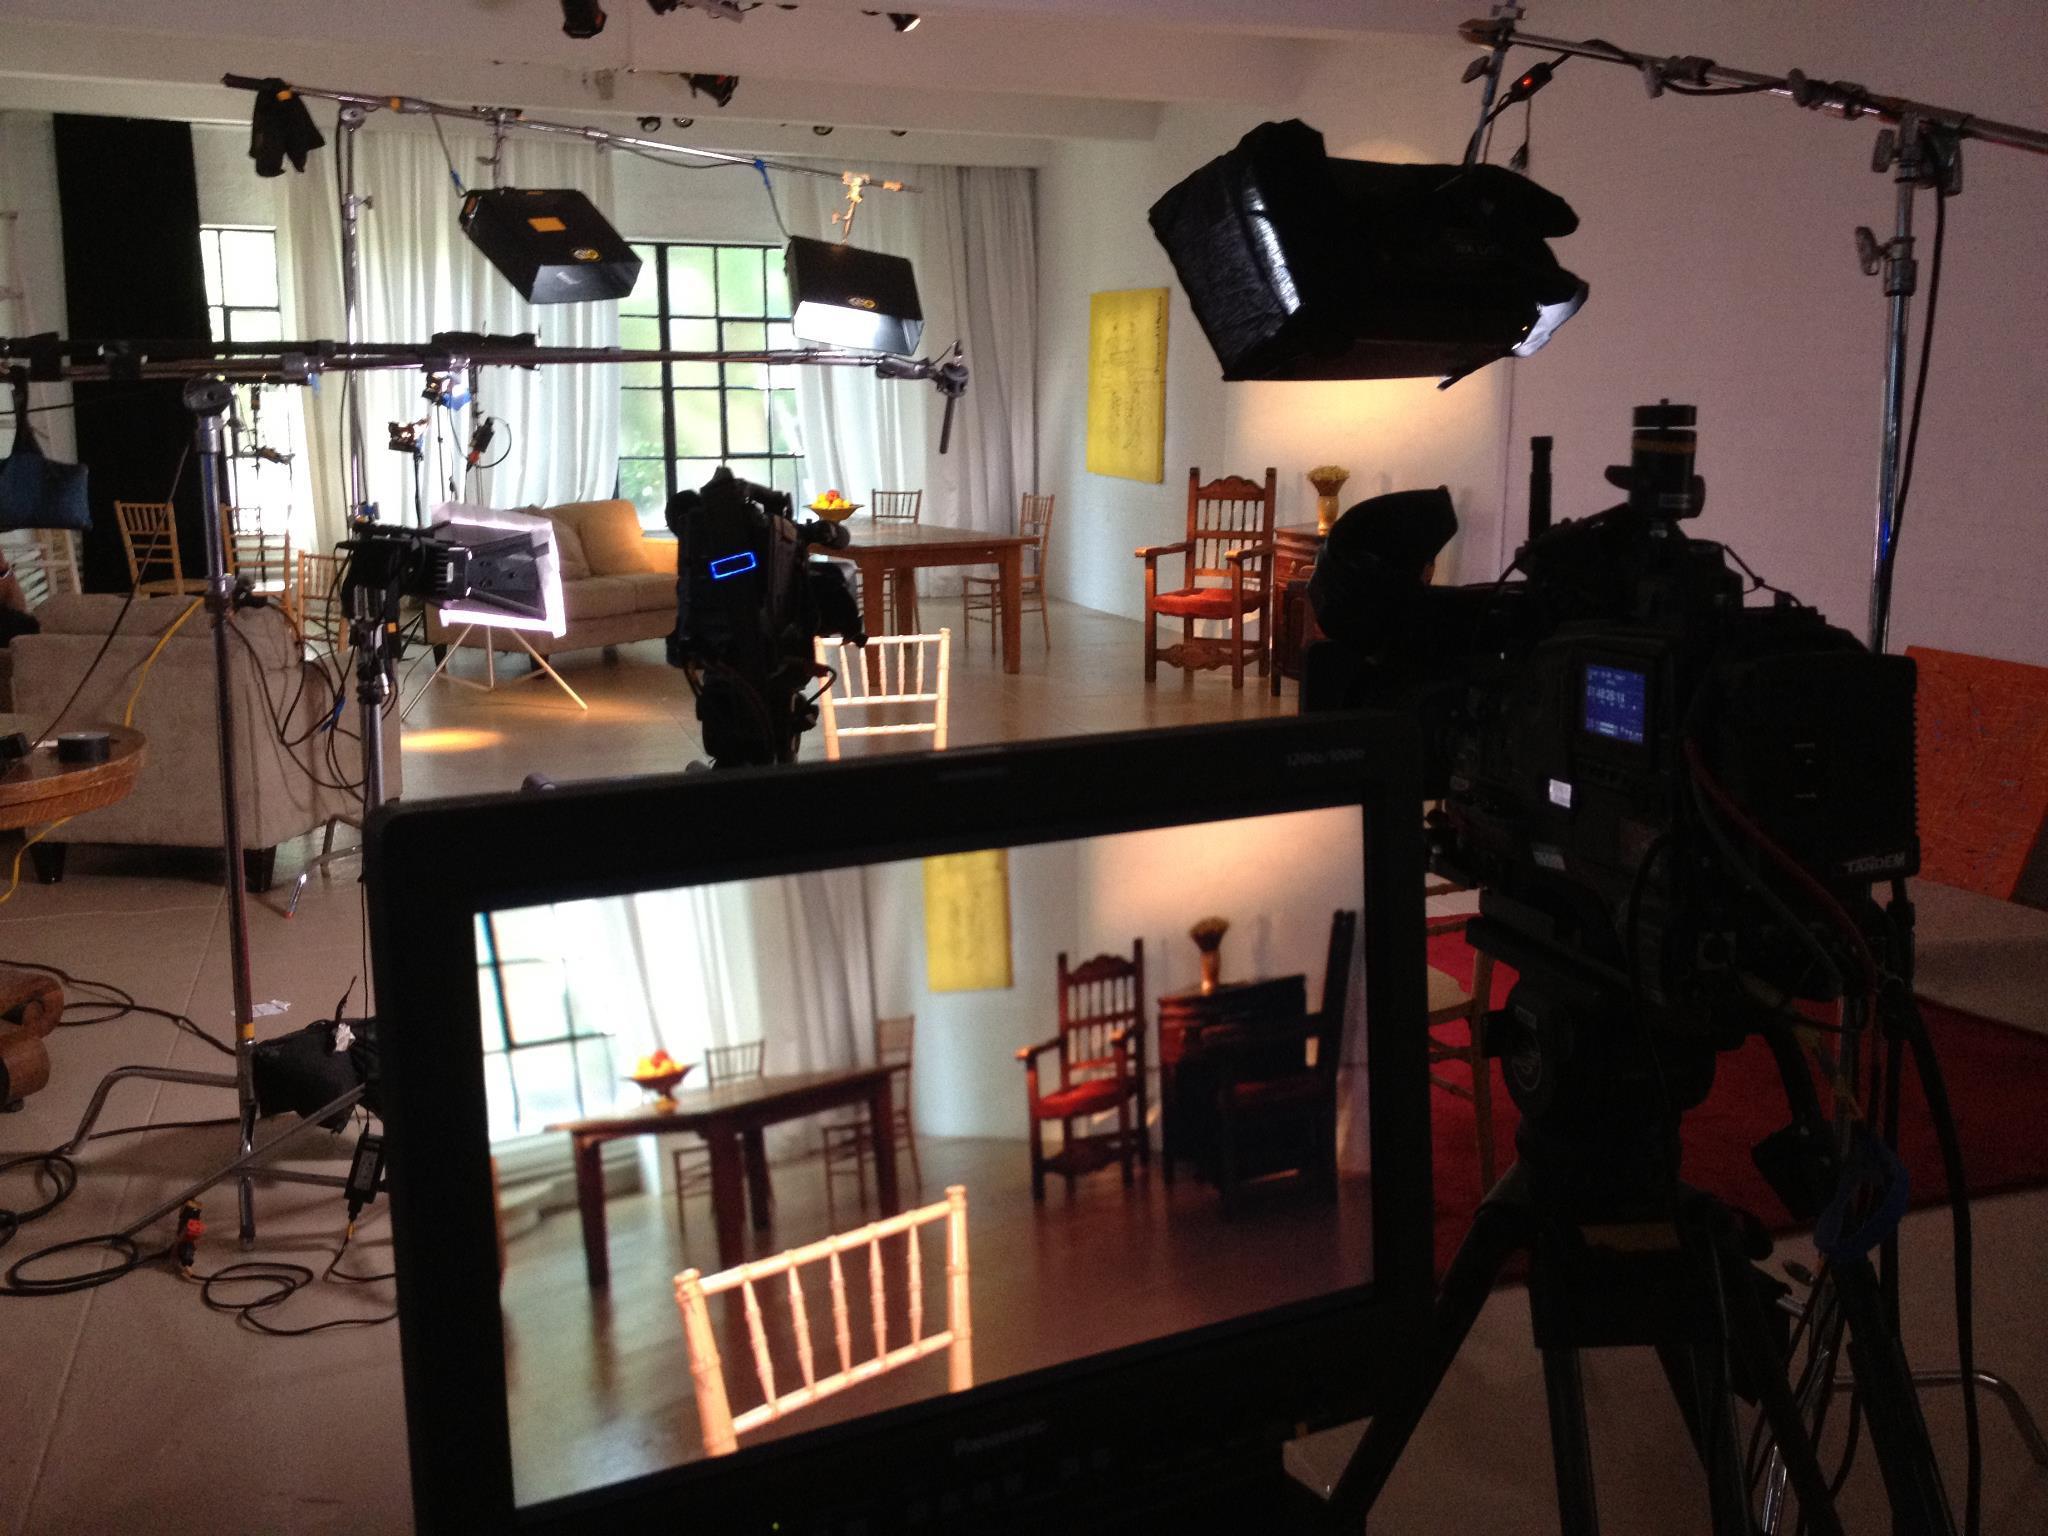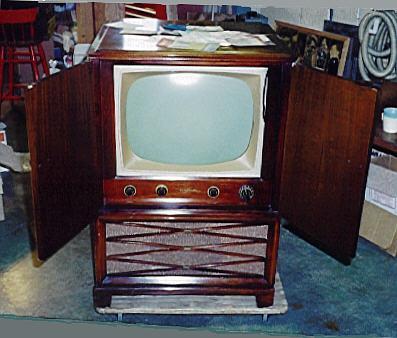The first image is the image on the left, the second image is the image on the right. Given the left and right images, does the statement "A single console television sits in the image on the right." hold true? Answer yes or no. Yes. The first image is the image on the left, the second image is the image on the right. For the images displayed, is the sentence "At least one television is on." factually correct? Answer yes or no. Yes. 